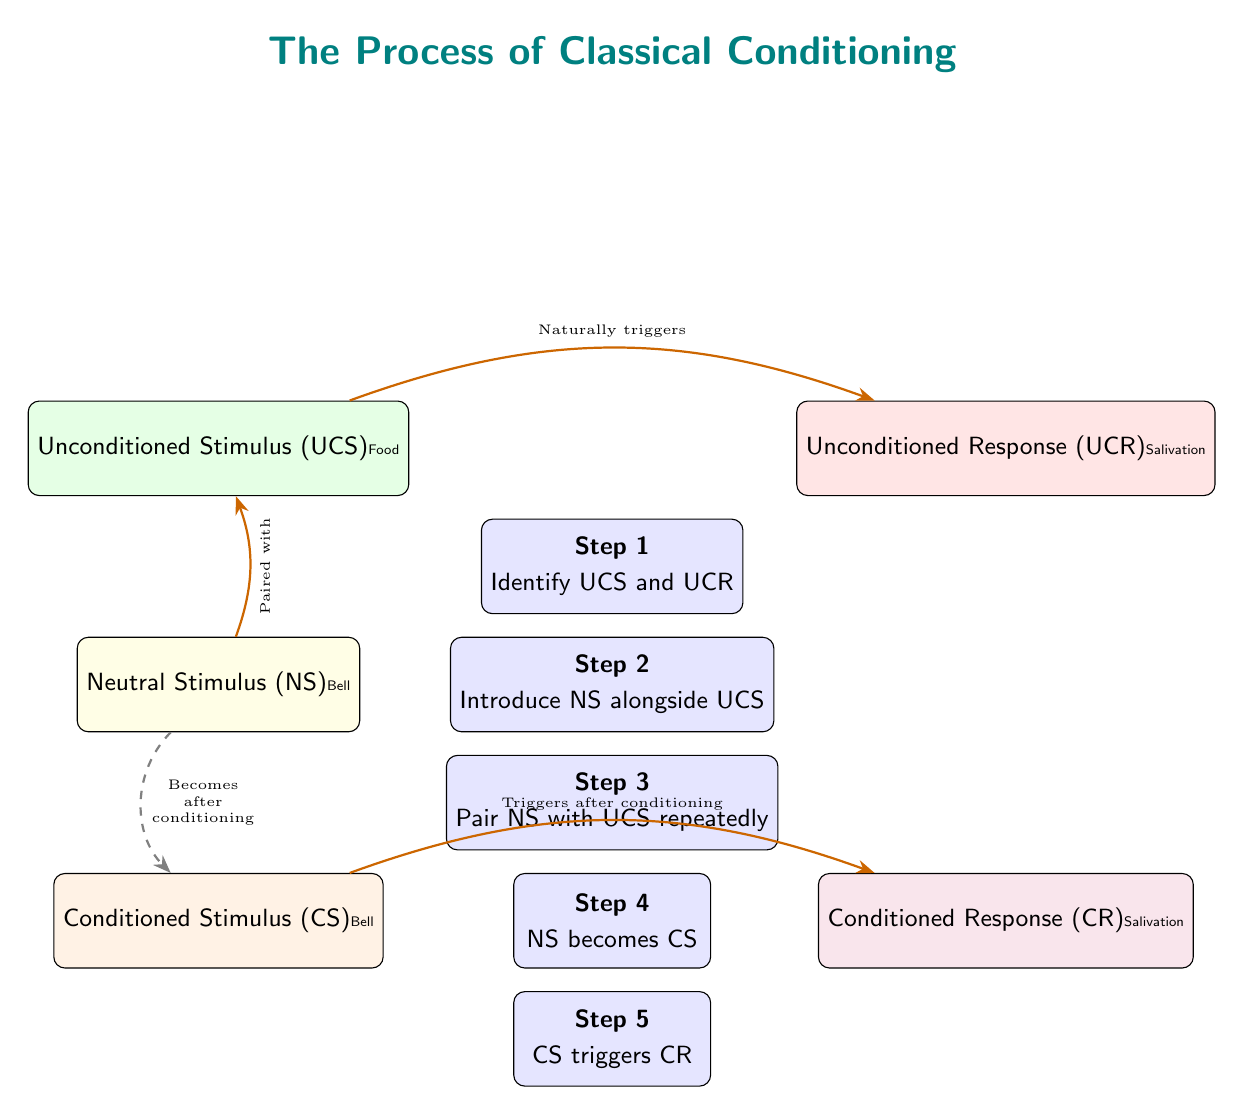What is the Unconditioned Stimulus (UCS) in this diagram? The Unconditioned Stimulus (UCS) is located on the left side of the diagram in the first box. It is labeled "Food."
Answer: Food What is the relationship between the Neutral Stimulus (NS) and the Unconditioned Stimulus (UCS)? The diagram shows an arrow from the NS box to the UCS box, with a label stating "Paired with." This indicates that the Neutral Stimulus is paired with the Unconditioned Stimulus in the process of conditioning.
Answer: Paired with How many steps are shown in the classical conditioning process? The diagram has five numbered steps, which are clearly labeled inside the boxes.
Answer: 5 What does the Conditioned Stimulus (CS) trigger? According to the diagram, there is an arrow leading from the CS to the CR box, with the label "Triggers after conditioning." Therefore, the CS triggers the Conditioned Response (CR).
Answer: Conditioned Response (CR) What transformation occurs from the Neutral Stimulus (NS) to the Conditioned Stimulus (CS)? The diagram shows a dashed arrow with a label reading "Becomes after conditioning," indicating that the NS transforms into the CS after conditioning is complete.
Answer: Becomes after conditioning What is the Unconditioned Response (UCR) described in the diagram? The Unconditioned Response (UCR) is shown in the right box next to the UCS, labeled "Salivation." This indicates the automatic response triggered by the UCS.
Answer: Salivation What is the order of the steps in the classical conditioning process? The steps are presented in a numbered sequence from 1 to 5, which shows the progression from identifying the UCS and UCR to the CS triggering the CR. The order is: Identify UCS and UCR, Introduce NS alongside UCS, Pair NS with UCS repeatedly, NS becomes CS, CS triggers CR.
Answer: Identify UCS and UCR, Introduce NS alongside UCS, Pair NS with UCS repeatedly, NS becomes CS, CS triggers CR What type of stimulus is the bell categorized as before conditioning? Before conditioning, the bell is designated as a Neutral Stimulus (NS) according to the diagram. This is shown in the relevant box labeled "Bell" under the NS section.
Answer: Neutral Stimulus (NS) How is the Unconditioned Response (UCR) related to the Conditioned Response (CR)? The diagram shows a direct relationship where the UCR is a natural response to the UCS (Food) and after conditioning, the CS (Bell) leads to the CR, which is the same response, salivation. This indicates that the CR is learned and mirrors the UCR.
Answer: Both trigger salivation 